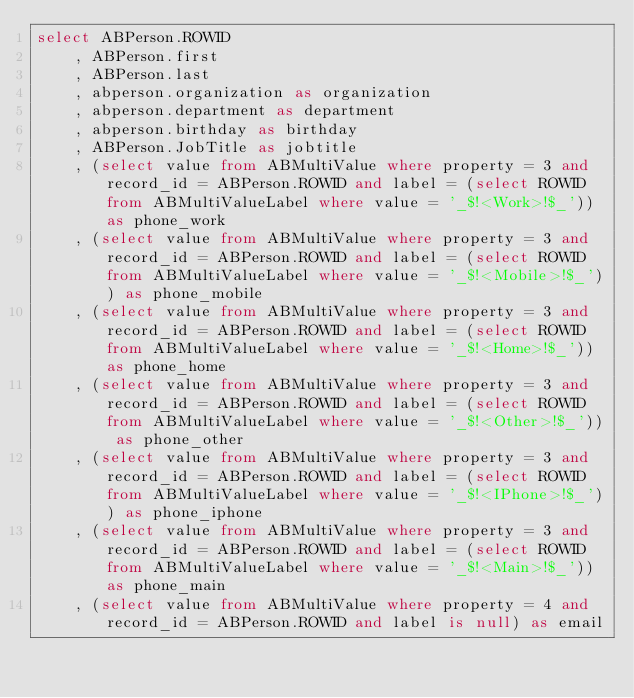Convert code to text. <code><loc_0><loc_0><loc_500><loc_500><_SQL_>select ABPerson.ROWID
    , ABPerson.first
    , ABPerson.last
    , abperson.organization as organization
    , abperson.department as department
    , abperson.birthday as birthday
    , ABPerson.JobTitle as jobtitle
    , (select value from ABMultiValue where property = 3 and record_id = ABPerson.ROWID and label = (select ROWID from ABMultiValueLabel where value = '_$!<Work>!$_')) as phone_work
    , (select value from ABMultiValue where property = 3 and record_id = ABPerson.ROWID and label = (select ROWID from ABMultiValueLabel where value = '_$!<Mobile>!$_')) as phone_mobile
    , (select value from ABMultiValue where property = 3 and record_id = ABPerson.ROWID and label = (select ROWID from ABMultiValueLabel where value = '_$!<Home>!$_')) as phone_home
    , (select value from ABMultiValue where property = 3 and record_id = ABPerson.ROWID and label = (select ROWID from ABMultiValueLabel where value = '_$!<Other>!$_')) as phone_other
    , (select value from ABMultiValue where property = 3 and record_id = ABPerson.ROWID and label = (select ROWID from ABMultiValueLabel where value = '_$!<IPhone>!$_')) as phone_iphone
    , (select value from ABMultiValue where property = 3 and record_id = ABPerson.ROWID and label = (select ROWID from ABMultiValueLabel where value = '_$!<Main>!$_')) as phone_main
    , (select value from ABMultiValue where property = 4 and record_id = ABPerson.ROWID and label is null) as email</code> 